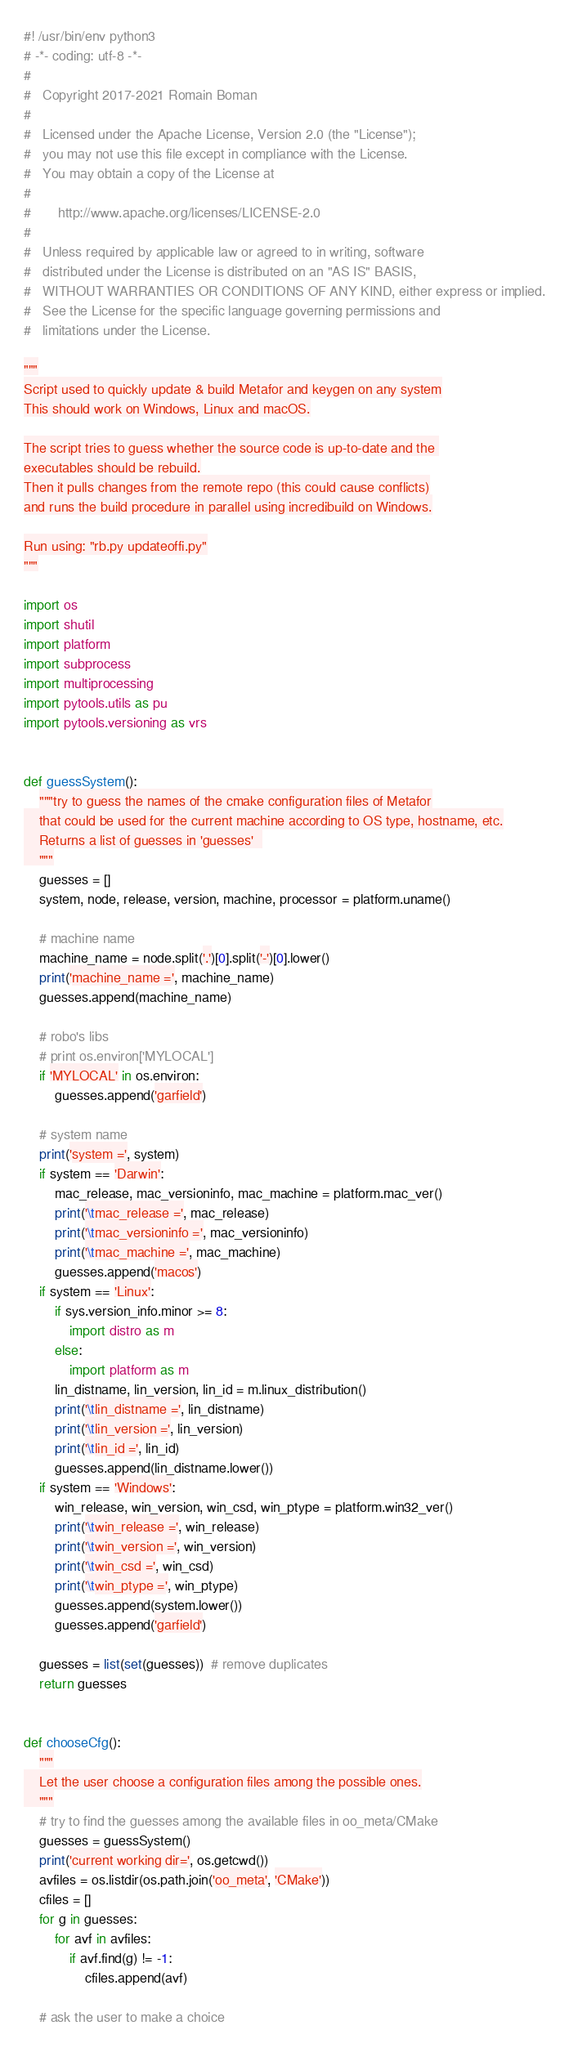Convert code to text. <code><loc_0><loc_0><loc_500><loc_500><_Python_>#! /usr/bin/env python3
# -*- coding: utf-8 -*-
#
#   Copyright 2017-2021 Romain Boman
#
#   Licensed under the Apache License, Version 2.0 (the "License");
#   you may not use this file except in compliance with the License.
#   You may obtain a copy of the License at
#
#       http://www.apache.org/licenses/LICENSE-2.0
#
#   Unless required by applicable law or agreed to in writing, software
#   distributed under the License is distributed on an "AS IS" BASIS,
#   WITHOUT WARRANTIES OR CONDITIONS OF ANY KIND, either express or implied.
#   See the License for the specific language governing permissions and
#   limitations under the License.

"""
Script used to quickly update & build Metafor and keygen on any system
This should work on Windows, Linux and macOS.

The script tries to guess whether the source code is up-to-date and the 
executables should be rebuild.
Then it pulls changes from the remote repo (this could cause conflicts)
and runs the build procedure in parallel using incredibuild on Windows.

Run using: "rb.py updateoffi.py"
"""

import os
import shutil
import platform
import subprocess
import multiprocessing
import pytools.utils as pu
import pytools.versioning as vrs


def guessSystem():
    """try to guess the names of the cmake configuration files of Metafor
    that could be used for the current machine according to OS type, hostname, etc.
    Returns a list of guesses in 'guesses'  
    """
    guesses = []
    system, node, release, version, machine, processor = platform.uname()

    # machine name
    machine_name = node.split('.')[0].split('-')[0].lower()
    print('machine_name =', machine_name)
    guesses.append(machine_name)

    # robo's libs
    # print os.environ['MYLOCAL']
    if 'MYLOCAL' in os.environ:
        guesses.append('garfield')

    # system name
    print('system =', system)
    if system == 'Darwin':
        mac_release, mac_versioninfo, mac_machine = platform.mac_ver()
        print('\tmac_release =', mac_release)
        print('\tmac_versioninfo =', mac_versioninfo)
        print('\tmac_machine =', mac_machine)
        guesses.append('macos')
    if system == 'Linux':
        if sys.version_info.minor >= 8:
            import distro as m
        else:
            import platform as m
        lin_distname, lin_version, lin_id = m.linux_distribution()
        print('\tlin_distname =', lin_distname)
        print('\tlin_version =', lin_version)
        print('\tlin_id =', lin_id)
        guesses.append(lin_distname.lower())
    if system == 'Windows':
        win_release, win_version, win_csd, win_ptype = platform.win32_ver()
        print('\twin_release =', win_release)
        print('\twin_version =', win_version)
        print('\twin_csd =', win_csd)
        print('\twin_ptype =', win_ptype)
        guesses.append(system.lower())
        guesses.append('garfield')

    guesses = list(set(guesses))  # remove duplicates
    return guesses


def chooseCfg():
    """
    Let the user choose a configuration files among the possible ones.
    """
    # try to find the guesses among the available files in oo_meta/CMake
    guesses = guessSystem()
    print('current working dir=', os.getcwd())
    avfiles = os.listdir(os.path.join('oo_meta', 'CMake'))
    cfiles = []
    for g in guesses:
        for avf in avfiles:
            if avf.find(g) != -1:
                cfiles.append(avf)

    # ask the user to make a choice</code> 